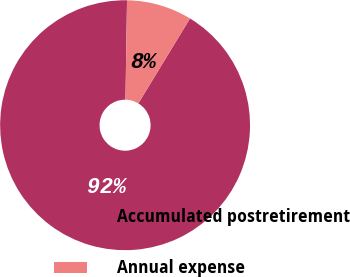Convert chart to OTSL. <chart><loc_0><loc_0><loc_500><loc_500><pie_chart><fcel>Accumulated postretirement<fcel>Annual expense<nl><fcel>91.55%<fcel>8.45%<nl></chart> 